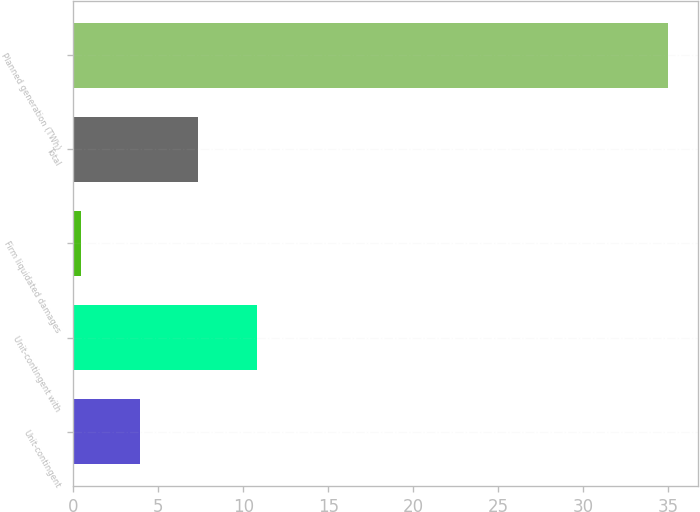Convert chart. <chart><loc_0><loc_0><loc_500><loc_500><bar_chart><fcel>Unit-contingent<fcel>Unit-contingent with<fcel>Firm liquidated damages<fcel>Total<fcel>Planned generation (TWh)<nl><fcel>3.91<fcel>10.81<fcel>0.46<fcel>7.36<fcel>35<nl></chart> 